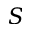<formula> <loc_0><loc_0><loc_500><loc_500>S</formula> 